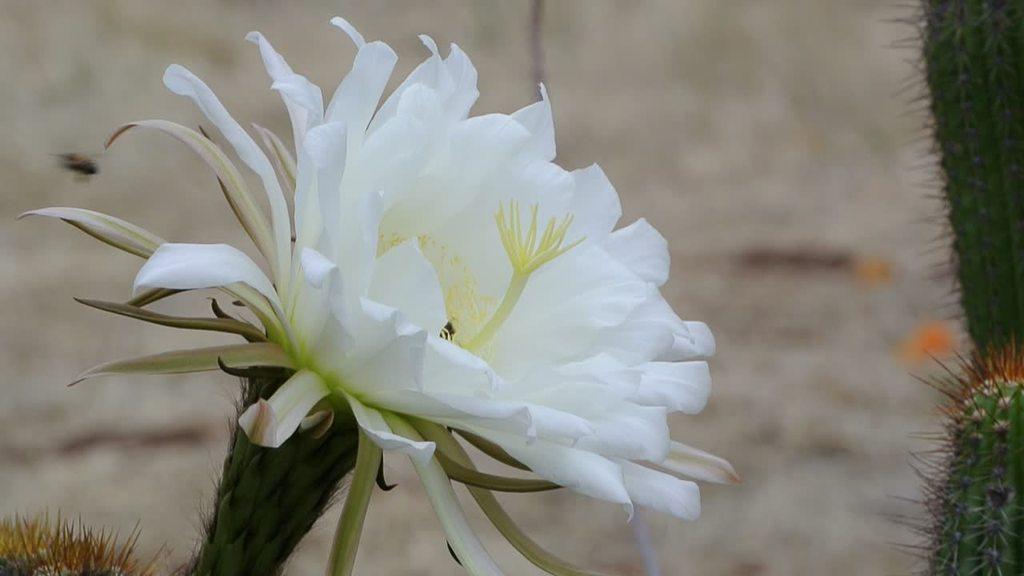In one or two sentences, can you explain what this image depicts? Here in this picture we can see a close up view of a white colored flower present on a plant and beside that we can see other plants also present and we can see the back ground is in blurry manner. 